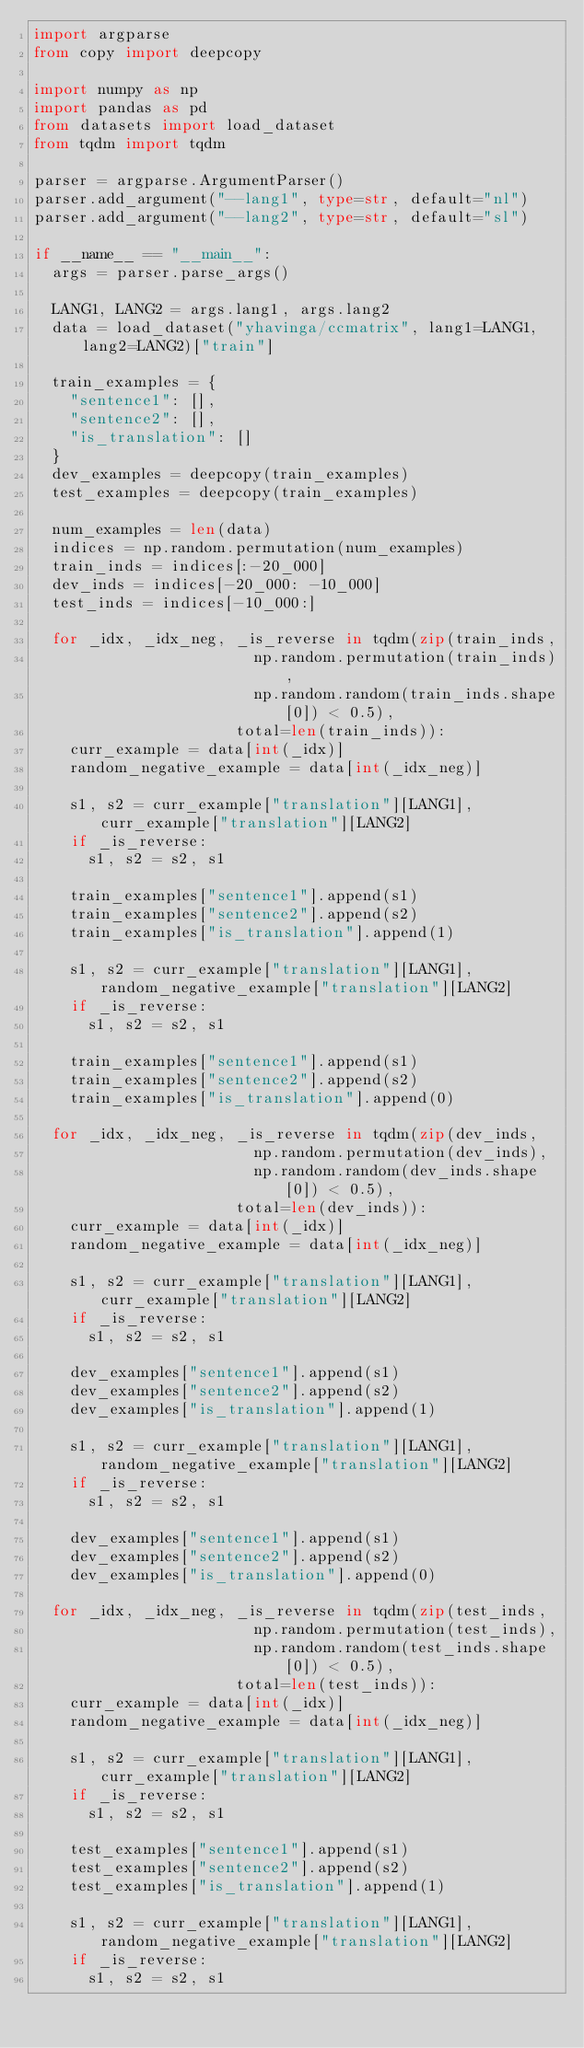<code> <loc_0><loc_0><loc_500><loc_500><_Python_>import argparse
from copy import deepcopy

import numpy as np
import pandas as pd
from datasets import load_dataset
from tqdm import tqdm

parser = argparse.ArgumentParser()
parser.add_argument("--lang1", type=str, default="nl")
parser.add_argument("--lang2", type=str, default="sl")

if __name__ == "__main__":
	args = parser.parse_args()

	LANG1, LANG2 = args.lang1, args.lang2
	data = load_dataset("yhavinga/ccmatrix", lang1=LANG1, lang2=LANG2)["train"]

	train_examples = {
		"sentence1": [],
		"sentence2": [],
		"is_translation": []
	}
	dev_examples = deepcopy(train_examples)
	test_examples = deepcopy(train_examples)

	num_examples = len(data)
	indices = np.random.permutation(num_examples)
	train_inds = indices[:-20_000]
	dev_inds = indices[-20_000: -10_000]
	test_inds = indices[-10_000:]

	for _idx, _idx_neg, _is_reverse in tqdm(zip(train_inds,
												np.random.permutation(train_inds),
												np.random.random(train_inds.shape[0]) < 0.5),
											total=len(train_inds)):
		curr_example = data[int(_idx)]
		random_negative_example = data[int(_idx_neg)]

		s1, s2 = curr_example["translation"][LANG1], curr_example["translation"][LANG2]
		if _is_reverse:
			s1, s2 = s2, s1

		train_examples["sentence1"].append(s1)
		train_examples["sentence2"].append(s2)
		train_examples["is_translation"].append(1)

		s1, s2 = curr_example["translation"][LANG1], random_negative_example["translation"][LANG2]
		if _is_reverse:
			s1, s2 = s2, s1

		train_examples["sentence1"].append(s1)
		train_examples["sentence2"].append(s2)
		train_examples["is_translation"].append(0)

	for _idx, _idx_neg, _is_reverse in tqdm(zip(dev_inds,
												np.random.permutation(dev_inds),
												np.random.random(dev_inds.shape[0]) < 0.5),
											total=len(dev_inds)):
		curr_example = data[int(_idx)]
		random_negative_example = data[int(_idx_neg)]

		s1, s2 = curr_example["translation"][LANG1], curr_example["translation"][LANG2]
		if _is_reverse:
			s1, s2 = s2, s1

		dev_examples["sentence1"].append(s1)
		dev_examples["sentence2"].append(s2)
		dev_examples["is_translation"].append(1)

		s1, s2 = curr_example["translation"][LANG1], random_negative_example["translation"][LANG2]
		if _is_reverse:
			s1, s2 = s2, s1

		dev_examples["sentence1"].append(s1)
		dev_examples["sentence2"].append(s2)
		dev_examples["is_translation"].append(0)

	for _idx, _idx_neg, _is_reverse in tqdm(zip(test_inds,
												np.random.permutation(test_inds),
												np.random.random(test_inds.shape[0]) < 0.5),
											total=len(test_inds)):
		curr_example = data[int(_idx)]
		random_negative_example = data[int(_idx_neg)]

		s1, s2 = curr_example["translation"][LANG1], curr_example["translation"][LANG2]
		if _is_reverse:
			s1, s2 = s2, s1

		test_examples["sentence1"].append(s1)
		test_examples["sentence2"].append(s2)
		test_examples["is_translation"].append(1)

		s1, s2 = curr_example["translation"][LANG1], random_negative_example["translation"][LANG2]
		if _is_reverse:
			s1, s2 = s2, s1
</code> 